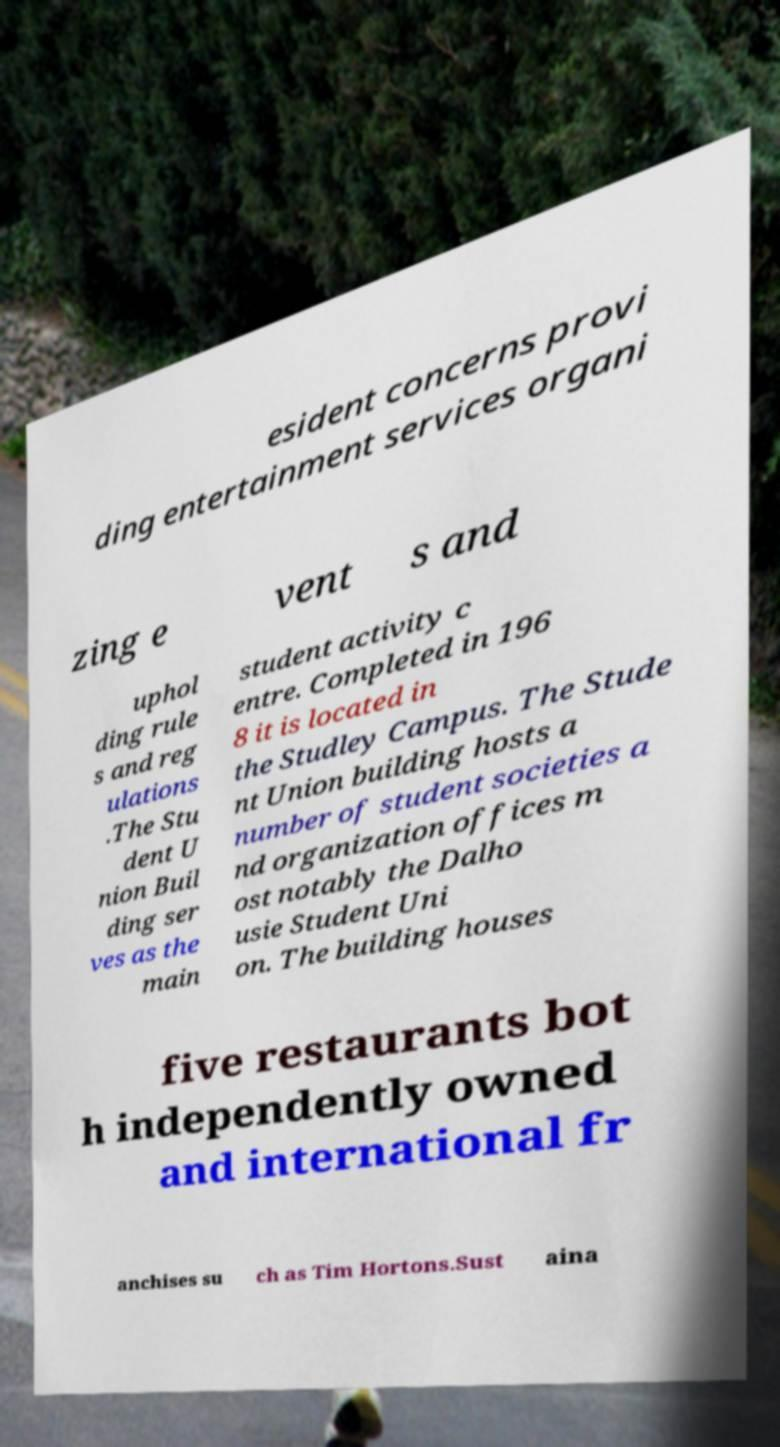Could you assist in decoding the text presented in this image and type it out clearly? esident concerns provi ding entertainment services organi zing e vent s and uphol ding rule s and reg ulations .The Stu dent U nion Buil ding ser ves as the main student activity c entre. Completed in 196 8 it is located in the Studley Campus. The Stude nt Union building hosts a number of student societies a nd organization offices m ost notably the Dalho usie Student Uni on. The building houses five restaurants bot h independently owned and international fr anchises su ch as Tim Hortons.Sust aina 